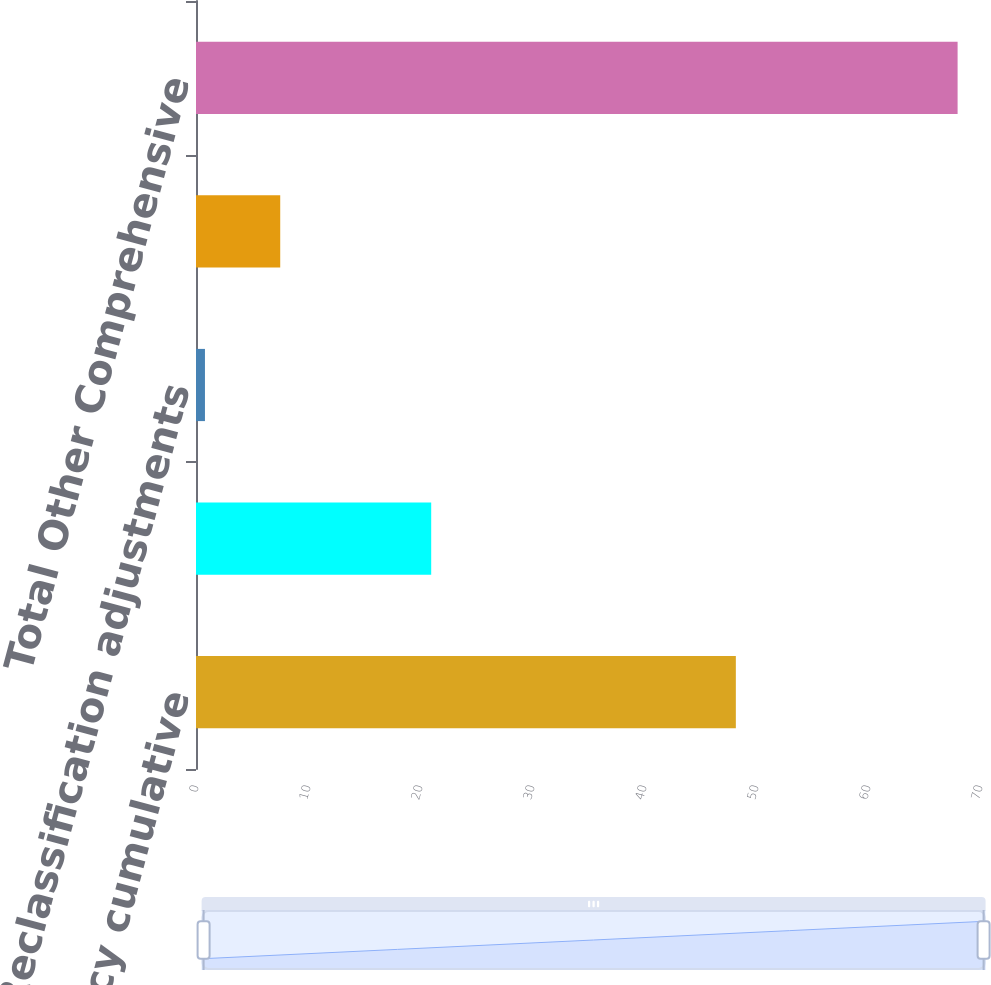Convert chart to OTSL. <chart><loc_0><loc_0><loc_500><loc_500><bar_chart><fcel>Foreign currency cumulative<fcel>Unrealized cash flow hedge<fcel>Reclassification adjustments<fcel>Adjustments to prior service<fcel>Total Other Comprehensive<nl><fcel>48.2<fcel>21<fcel>0.8<fcel>7.52<fcel>68<nl></chart> 